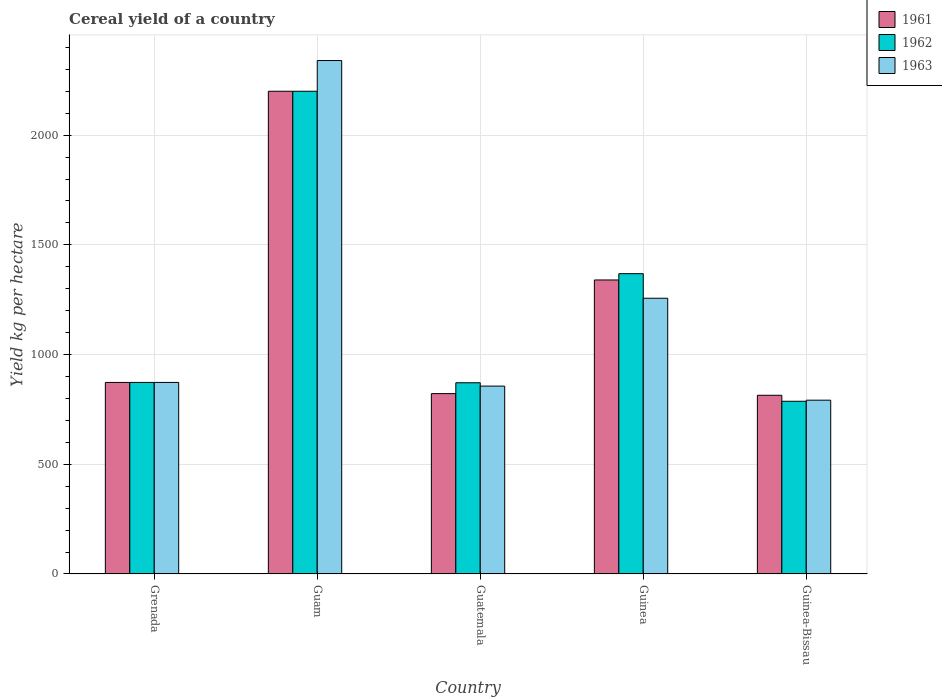Are the number of bars per tick equal to the number of legend labels?
Offer a very short reply. Yes. Are the number of bars on each tick of the X-axis equal?
Keep it short and to the point. Yes. What is the label of the 5th group of bars from the left?
Give a very brief answer. Guinea-Bissau. What is the total cereal yield in 1961 in Guinea?
Offer a terse response. 1340. Across all countries, what is the maximum total cereal yield in 1963?
Your answer should be compact. 2340. Across all countries, what is the minimum total cereal yield in 1962?
Provide a short and direct response. 787.13. In which country was the total cereal yield in 1962 maximum?
Provide a short and direct response. Guam. In which country was the total cereal yield in 1963 minimum?
Your answer should be compact. Guinea-Bissau. What is the total total cereal yield in 1962 in the graph?
Your answer should be compact. 6100.28. What is the difference between the total cereal yield in 1961 in Guam and that in Guatemala?
Provide a succinct answer. 1377.88. What is the difference between the total cereal yield in 1962 in Guinea and the total cereal yield in 1961 in Guinea-Bissau?
Offer a very short reply. 554.22. What is the average total cereal yield in 1962 per country?
Your response must be concise. 1220.06. What is the difference between the total cereal yield of/in 1961 and total cereal yield of/in 1962 in Guinea-Bissau?
Ensure brevity in your answer.  27.3. What is the ratio of the total cereal yield in 1961 in Guam to that in Guinea-Bissau?
Offer a terse response. 2.7. What is the difference between the highest and the second highest total cereal yield in 1962?
Offer a terse response. 1326.98. What is the difference between the highest and the lowest total cereal yield in 1962?
Provide a succinct answer. 1412.87. What does the 2nd bar from the left in Grenada represents?
Your answer should be very brief. 1962. What does the 2nd bar from the right in Guatemala represents?
Provide a succinct answer. 1962. Is it the case that in every country, the sum of the total cereal yield in 1961 and total cereal yield in 1963 is greater than the total cereal yield in 1962?
Ensure brevity in your answer.  Yes. Are all the bars in the graph horizontal?
Make the answer very short. No. How many countries are there in the graph?
Give a very brief answer. 5. Are the values on the major ticks of Y-axis written in scientific E-notation?
Provide a short and direct response. No. Does the graph contain any zero values?
Offer a terse response. No. Where does the legend appear in the graph?
Offer a very short reply. Top right. What is the title of the graph?
Make the answer very short. Cereal yield of a country. What is the label or title of the X-axis?
Make the answer very short. Country. What is the label or title of the Y-axis?
Your response must be concise. Yield kg per hectare. What is the Yield kg per hectare in 1961 in Grenada?
Provide a short and direct response. 873.02. What is the Yield kg per hectare in 1962 in Grenada?
Make the answer very short. 873.02. What is the Yield kg per hectare of 1963 in Grenada?
Your answer should be very brief. 873.02. What is the Yield kg per hectare in 1961 in Guam?
Offer a terse response. 2200. What is the Yield kg per hectare in 1962 in Guam?
Provide a short and direct response. 2200. What is the Yield kg per hectare in 1963 in Guam?
Keep it short and to the point. 2340. What is the Yield kg per hectare of 1961 in Guatemala?
Give a very brief answer. 822.12. What is the Yield kg per hectare in 1962 in Guatemala?
Make the answer very short. 871.48. What is the Yield kg per hectare of 1963 in Guatemala?
Make the answer very short. 856.3. What is the Yield kg per hectare of 1961 in Guinea?
Ensure brevity in your answer.  1340. What is the Yield kg per hectare of 1962 in Guinea?
Ensure brevity in your answer.  1368.66. What is the Yield kg per hectare of 1963 in Guinea?
Ensure brevity in your answer.  1256.66. What is the Yield kg per hectare in 1961 in Guinea-Bissau?
Offer a very short reply. 814.43. What is the Yield kg per hectare of 1962 in Guinea-Bissau?
Your response must be concise. 787.13. What is the Yield kg per hectare in 1963 in Guinea-Bissau?
Ensure brevity in your answer.  792.08. Across all countries, what is the maximum Yield kg per hectare of 1961?
Make the answer very short. 2200. Across all countries, what is the maximum Yield kg per hectare in 1962?
Give a very brief answer. 2200. Across all countries, what is the maximum Yield kg per hectare of 1963?
Provide a short and direct response. 2340. Across all countries, what is the minimum Yield kg per hectare of 1961?
Ensure brevity in your answer.  814.43. Across all countries, what is the minimum Yield kg per hectare of 1962?
Your answer should be compact. 787.13. Across all countries, what is the minimum Yield kg per hectare of 1963?
Offer a terse response. 792.08. What is the total Yield kg per hectare in 1961 in the graph?
Your answer should be compact. 6049.56. What is the total Yield kg per hectare in 1962 in the graph?
Provide a short and direct response. 6100.28. What is the total Yield kg per hectare in 1963 in the graph?
Offer a very short reply. 6118.06. What is the difference between the Yield kg per hectare of 1961 in Grenada and that in Guam?
Your response must be concise. -1326.98. What is the difference between the Yield kg per hectare in 1962 in Grenada and that in Guam?
Make the answer very short. -1326.98. What is the difference between the Yield kg per hectare of 1963 in Grenada and that in Guam?
Your answer should be very brief. -1466.98. What is the difference between the Yield kg per hectare of 1961 in Grenada and that in Guatemala?
Offer a terse response. 50.9. What is the difference between the Yield kg per hectare of 1962 in Grenada and that in Guatemala?
Give a very brief answer. 1.53. What is the difference between the Yield kg per hectare in 1963 in Grenada and that in Guatemala?
Keep it short and to the point. 16.72. What is the difference between the Yield kg per hectare of 1961 in Grenada and that in Guinea?
Offer a terse response. -466.98. What is the difference between the Yield kg per hectare in 1962 in Grenada and that in Guinea?
Ensure brevity in your answer.  -495.64. What is the difference between the Yield kg per hectare of 1963 in Grenada and that in Guinea?
Offer a terse response. -383.65. What is the difference between the Yield kg per hectare of 1961 in Grenada and that in Guinea-Bissau?
Your response must be concise. 58.58. What is the difference between the Yield kg per hectare in 1962 in Grenada and that in Guinea-Bissau?
Provide a succinct answer. 85.89. What is the difference between the Yield kg per hectare of 1963 in Grenada and that in Guinea-Bissau?
Provide a short and direct response. 80.94. What is the difference between the Yield kg per hectare of 1961 in Guam and that in Guatemala?
Keep it short and to the point. 1377.88. What is the difference between the Yield kg per hectare in 1962 in Guam and that in Guatemala?
Offer a very short reply. 1328.52. What is the difference between the Yield kg per hectare of 1963 in Guam and that in Guatemala?
Make the answer very short. 1483.7. What is the difference between the Yield kg per hectare of 1961 in Guam and that in Guinea?
Offer a very short reply. 860. What is the difference between the Yield kg per hectare in 1962 in Guam and that in Guinea?
Your answer should be compact. 831.34. What is the difference between the Yield kg per hectare of 1963 in Guam and that in Guinea?
Ensure brevity in your answer.  1083.34. What is the difference between the Yield kg per hectare of 1961 in Guam and that in Guinea-Bissau?
Your answer should be compact. 1385.57. What is the difference between the Yield kg per hectare in 1962 in Guam and that in Guinea-Bissau?
Your answer should be very brief. 1412.87. What is the difference between the Yield kg per hectare in 1963 in Guam and that in Guinea-Bissau?
Provide a short and direct response. 1547.92. What is the difference between the Yield kg per hectare in 1961 in Guatemala and that in Guinea?
Keep it short and to the point. -517.88. What is the difference between the Yield kg per hectare in 1962 in Guatemala and that in Guinea?
Your answer should be compact. -497.17. What is the difference between the Yield kg per hectare in 1963 in Guatemala and that in Guinea?
Ensure brevity in your answer.  -400.37. What is the difference between the Yield kg per hectare of 1961 in Guatemala and that in Guinea-Bissau?
Keep it short and to the point. 7.68. What is the difference between the Yield kg per hectare in 1962 in Guatemala and that in Guinea-Bissau?
Provide a succinct answer. 84.35. What is the difference between the Yield kg per hectare in 1963 in Guatemala and that in Guinea-Bissau?
Give a very brief answer. 64.22. What is the difference between the Yield kg per hectare of 1961 in Guinea and that in Guinea-Bissau?
Offer a terse response. 525.57. What is the difference between the Yield kg per hectare in 1962 in Guinea and that in Guinea-Bissau?
Make the answer very short. 581.53. What is the difference between the Yield kg per hectare of 1963 in Guinea and that in Guinea-Bissau?
Give a very brief answer. 464.59. What is the difference between the Yield kg per hectare of 1961 in Grenada and the Yield kg per hectare of 1962 in Guam?
Make the answer very short. -1326.98. What is the difference between the Yield kg per hectare in 1961 in Grenada and the Yield kg per hectare in 1963 in Guam?
Give a very brief answer. -1466.98. What is the difference between the Yield kg per hectare of 1962 in Grenada and the Yield kg per hectare of 1963 in Guam?
Provide a short and direct response. -1466.98. What is the difference between the Yield kg per hectare in 1961 in Grenada and the Yield kg per hectare in 1962 in Guatemala?
Your answer should be very brief. 1.53. What is the difference between the Yield kg per hectare of 1961 in Grenada and the Yield kg per hectare of 1963 in Guatemala?
Ensure brevity in your answer.  16.72. What is the difference between the Yield kg per hectare in 1962 in Grenada and the Yield kg per hectare in 1963 in Guatemala?
Offer a very short reply. 16.72. What is the difference between the Yield kg per hectare of 1961 in Grenada and the Yield kg per hectare of 1962 in Guinea?
Your answer should be compact. -495.64. What is the difference between the Yield kg per hectare of 1961 in Grenada and the Yield kg per hectare of 1963 in Guinea?
Keep it short and to the point. -383.65. What is the difference between the Yield kg per hectare in 1962 in Grenada and the Yield kg per hectare in 1963 in Guinea?
Your response must be concise. -383.65. What is the difference between the Yield kg per hectare of 1961 in Grenada and the Yield kg per hectare of 1962 in Guinea-Bissau?
Your answer should be very brief. 85.89. What is the difference between the Yield kg per hectare in 1961 in Grenada and the Yield kg per hectare in 1963 in Guinea-Bissau?
Your answer should be compact. 80.94. What is the difference between the Yield kg per hectare in 1962 in Grenada and the Yield kg per hectare in 1963 in Guinea-Bissau?
Give a very brief answer. 80.94. What is the difference between the Yield kg per hectare in 1961 in Guam and the Yield kg per hectare in 1962 in Guatemala?
Your answer should be very brief. 1328.52. What is the difference between the Yield kg per hectare of 1961 in Guam and the Yield kg per hectare of 1963 in Guatemala?
Provide a succinct answer. 1343.7. What is the difference between the Yield kg per hectare in 1962 in Guam and the Yield kg per hectare in 1963 in Guatemala?
Give a very brief answer. 1343.7. What is the difference between the Yield kg per hectare of 1961 in Guam and the Yield kg per hectare of 1962 in Guinea?
Your answer should be very brief. 831.34. What is the difference between the Yield kg per hectare of 1961 in Guam and the Yield kg per hectare of 1963 in Guinea?
Provide a succinct answer. 943.34. What is the difference between the Yield kg per hectare of 1962 in Guam and the Yield kg per hectare of 1963 in Guinea?
Provide a succinct answer. 943.34. What is the difference between the Yield kg per hectare in 1961 in Guam and the Yield kg per hectare in 1962 in Guinea-Bissau?
Provide a short and direct response. 1412.87. What is the difference between the Yield kg per hectare in 1961 in Guam and the Yield kg per hectare in 1963 in Guinea-Bissau?
Your response must be concise. 1407.92. What is the difference between the Yield kg per hectare in 1962 in Guam and the Yield kg per hectare in 1963 in Guinea-Bissau?
Offer a terse response. 1407.92. What is the difference between the Yield kg per hectare in 1961 in Guatemala and the Yield kg per hectare in 1962 in Guinea?
Your answer should be very brief. -546.54. What is the difference between the Yield kg per hectare of 1961 in Guatemala and the Yield kg per hectare of 1963 in Guinea?
Offer a very short reply. -434.55. What is the difference between the Yield kg per hectare in 1962 in Guatemala and the Yield kg per hectare in 1963 in Guinea?
Keep it short and to the point. -385.18. What is the difference between the Yield kg per hectare in 1961 in Guatemala and the Yield kg per hectare in 1962 in Guinea-Bissau?
Offer a very short reply. 34.99. What is the difference between the Yield kg per hectare in 1961 in Guatemala and the Yield kg per hectare in 1963 in Guinea-Bissau?
Provide a short and direct response. 30.04. What is the difference between the Yield kg per hectare of 1962 in Guatemala and the Yield kg per hectare of 1963 in Guinea-Bissau?
Offer a very short reply. 79.4. What is the difference between the Yield kg per hectare in 1961 in Guinea and the Yield kg per hectare in 1962 in Guinea-Bissau?
Provide a succinct answer. 552.87. What is the difference between the Yield kg per hectare of 1961 in Guinea and the Yield kg per hectare of 1963 in Guinea-Bissau?
Ensure brevity in your answer.  547.92. What is the difference between the Yield kg per hectare of 1962 in Guinea and the Yield kg per hectare of 1963 in Guinea-Bissau?
Offer a terse response. 576.58. What is the average Yield kg per hectare of 1961 per country?
Your answer should be very brief. 1209.91. What is the average Yield kg per hectare in 1962 per country?
Provide a succinct answer. 1220.06. What is the average Yield kg per hectare of 1963 per country?
Provide a succinct answer. 1223.61. What is the difference between the Yield kg per hectare of 1961 and Yield kg per hectare of 1963 in Guam?
Give a very brief answer. -140. What is the difference between the Yield kg per hectare of 1962 and Yield kg per hectare of 1963 in Guam?
Provide a short and direct response. -140. What is the difference between the Yield kg per hectare of 1961 and Yield kg per hectare of 1962 in Guatemala?
Ensure brevity in your answer.  -49.37. What is the difference between the Yield kg per hectare in 1961 and Yield kg per hectare in 1963 in Guatemala?
Ensure brevity in your answer.  -34.18. What is the difference between the Yield kg per hectare in 1962 and Yield kg per hectare in 1963 in Guatemala?
Your answer should be very brief. 15.19. What is the difference between the Yield kg per hectare of 1961 and Yield kg per hectare of 1962 in Guinea?
Give a very brief answer. -28.66. What is the difference between the Yield kg per hectare of 1961 and Yield kg per hectare of 1963 in Guinea?
Provide a succinct answer. 83.33. What is the difference between the Yield kg per hectare in 1962 and Yield kg per hectare in 1963 in Guinea?
Offer a terse response. 111.99. What is the difference between the Yield kg per hectare in 1961 and Yield kg per hectare in 1962 in Guinea-Bissau?
Give a very brief answer. 27.3. What is the difference between the Yield kg per hectare of 1961 and Yield kg per hectare of 1963 in Guinea-Bissau?
Make the answer very short. 22.35. What is the difference between the Yield kg per hectare of 1962 and Yield kg per hectare of 1963 in Guinea-Bissau?
Give a very brief answer. -4.95. What is the ratio of the Yield kg per hectare of 1961 in Grenada to that in Guam?
Give a very brief answer. 0.4. What is the ratio of the Yield kg per hectare in 1962 in Grenada to that in Guam?
Your response must be concise. 0.4. What is the ratio of the Yield kg per hectare of 1963 in Grenada to that in Guam?
Make the answer very short. 0.37. What is the ratio of the Yield kg per hectare in 1961 in Grenada to that in Guatemala?
Give a very brief answer. 1.06. What is the ratio of the Yield kg per hectare of 1962 in Grenada to that in Guatemala?
Ensure brevity in your answer.  1. What is the ratio of the Yield kg per hectare in 1963 in Grenada to that in Guatemala?
Provide a succinct answer. 1.02. What is the ratio of the Yield kg per hectare in 1961 in Grenada to that in Guinea?
Provide a short and direct response. 0.65. What is the ratio of the Yield kg per hectare in 1962 in Grenada to that in Guinea?
Make the answer very short. 0.64. What is the ratio of the Yield kg per hectare of 1963 in Grenada to that in Guinea?
Keep it short and to the point. 0.69. What is the ratio of the Yield kg per hectare in 1961 in Grenada to that in Guinea-Bissau?
Your answer should be very brief. 1.07. What is the ratio of the Yield kg per hectare of 1962 in Grenada to that in Guinea-Bissau?
Offer a terse response. 1.11. What is the ratio of the Yield kg per hectare of 1963 in Grenada to that in Guinea-Bissau?
Ensure brevity in your answer.  1.1. What is the ratio of the Yield kg per hectare in 1961 in Guam to that in Guatemala?
Keep it short and to the point. 2.68. What is the ratio of the Yield kg per hectare of 1962 in Guam to that in Guatemala?
Provide a succinct answer. 2.52. What is the ratio of the Yield kg per hectare of 1963 in Guam to that in Guatemala?
Make the answer very short. 2.73. What is the ratio of the Yield kg per hectare in 1961 in Guam to that in Guinea?
Your answer should be very brief. 1.64. What is the ratio of the Yield kg per hectare of 1962 in Guam to that in Guinea?
Your answer should be very brief. 1.61. What is the ratio of the Yield kg per hectare in 1963 in Guam to that in Guinea?
Ensure brevity in your answer.  1.86. What is the ratio of the Yield kg per hectare of 1961 in Guam to that in Guinea-Bissau?
Keep it short and to the point. 2.7. What is the ratio of the Yield kg per hectare of 1962 in Guam to that in Guinea-Bissau?
Your response must be concise. 2.79. What is the ratio of the Yield kg per hectare of 1963 in Guam to that in Guinea-Bissau?
Make the answer very short. 2.95. What is the ratio of the Yield kg per hectare in 1961 in Guatemala to that in Guinea?
Provide a short and direct response. 0.61. What is the ratio of the Yield kg per hectare of 1962 in Guatemala to that in Guinea?
Offer a very short reply. 0.64. What is the ratio of the Yield kg per hectare of 1963 in Guatemala to that in Guinea?
Keep it short and to the point. 0.68. What is the ratio of the Yield kg per hectare in 1961 in Guatemala to that in Guinea-Bissau?
Give a very brief answer. 1.01. What is the ratio of the Yield kg per hectare in 1962 in Guatemala to that in Guinea-Bissau?
Provide a short and direct response. 1.11. What is the ratio of the Yield kg per hectare in 1963 in Guatemala to that in Guinea-Bissau?
Provide a short and direct response. 1.08. What is the ratio of the Yield kg per hectare of 1961 in Guinea to that in Guinea-Bissau?
Make the answer very short. 1.65. What is the ratio of the Yield kg per hectare of 1962 in Guinea to that in Guinea-Bissau?
Your answer should be compact. 1.74. What is the ratio of the Yield kg per hectare of 1963 in Guinea to that in Guinea-Bissau?
Give a very brief answer. 1.59. What is the difference between the highest and the second highest Yield kg per hectare of 1961?
Your answer should be compact. 860. What is the difference between the highest and the second highest Yield kg per hectare in 1962?
Provide a short and direct response. 831.34. What is the difference between the highest and the second highest Yield kg per hectare of 1963?
Make the answer very short. 1083.34. What is the difference between the highest and the lowest Yield kg per hectare of 1961?
Your answer should be compact. 1385.57. What is the difference between the highest and the lowest Yield kg per hectare in 1962?
Your answer should be compact. 1412.87. What is the difference between the highest and the lowest Yield kg per hectare in 1963?
Your answer should be very brief. 1547.92. 